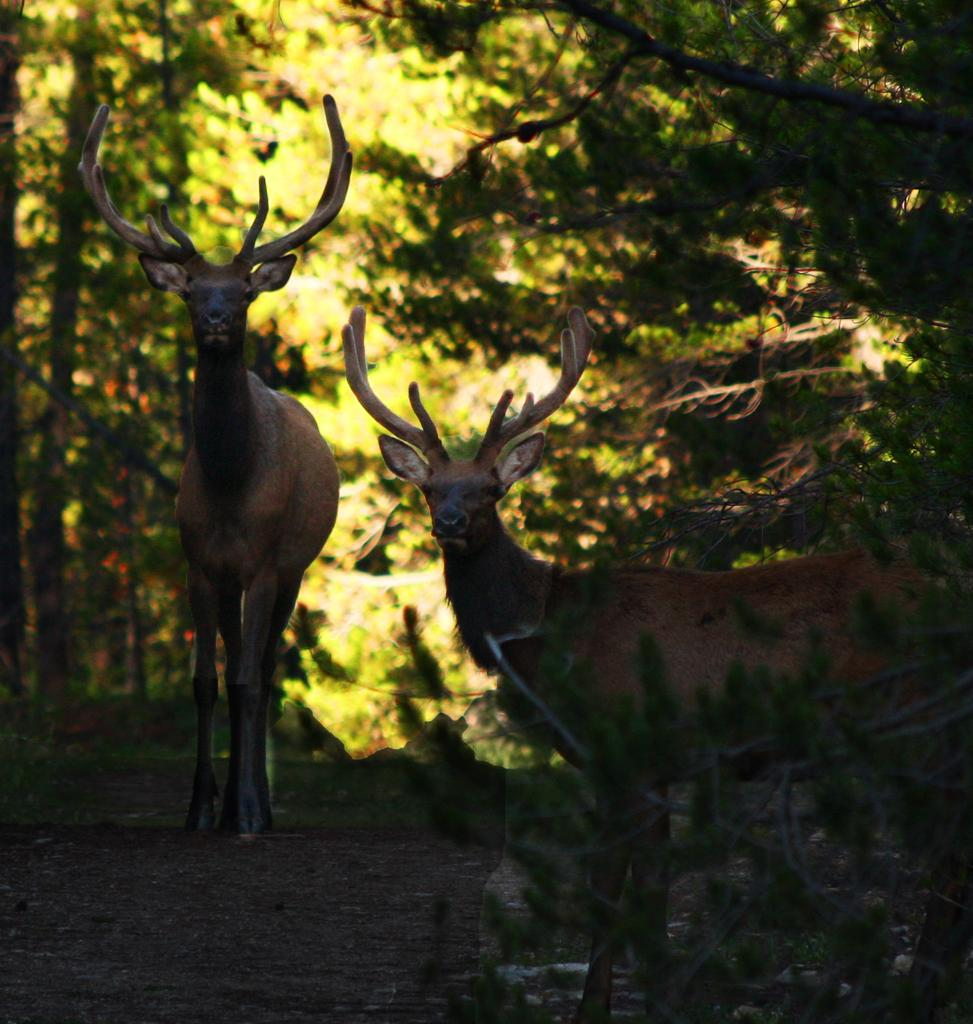How many animals are present in the image? There are two animals in the image. What can be seen in the background of the image? There are trees in the background of the image. Reasoning: Let' Let's think step by step in order to produce the conversation. We start by identifying the main subjects in the image, which are the two animals. Then, we expand the conversation to include the background of the image, which features trees. Each question is designed to elicit a specific detail about the image that is known from the provided facts. Absurd Question/Answer: How many dolls are present in the image? There are no dolls present in the image; it features two animals. What type of love is being expressed by the ladybug in the image? There is no ladybug present in the image, so it is not possible to determine what type of love might be expressed. How many dolls are present in the image? There are no dolls present in the image; it features two animals. What type of love is being expressed by the ladybug in the image? There is no ladybug present in the image, so it is not possible to determine what type of love might be expressed. 